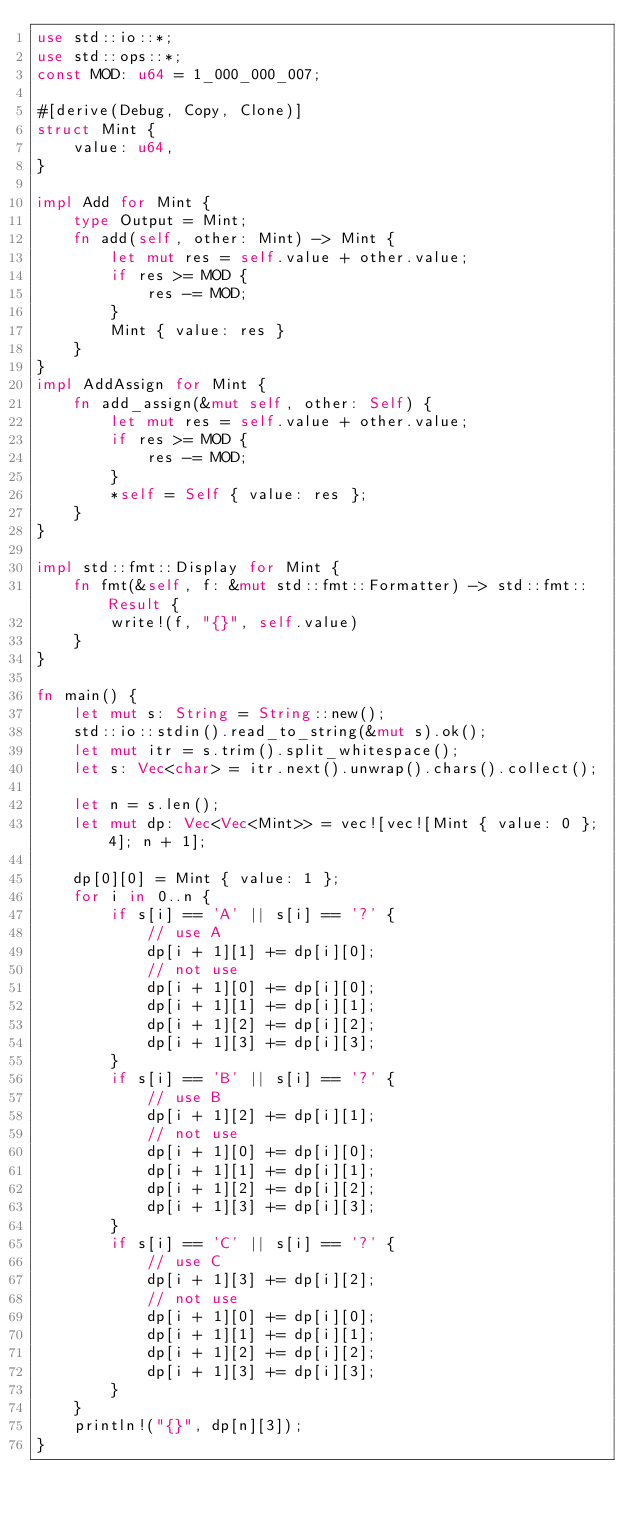Convert code to text. <code><loc_0><loc_0><loc_500><loc_500><_Rust_>use std::io::*;
use std::ops::*;
const MOD: u64 = 1_000_000_007;

#[derive(Debug, Copy, Clone)]
struct Mint {
    value: u64,
}

impl Add for Mint {
    type Output = Mint;
    fn add(self, other: Mint) -> Mint {
        let mut res = self.value + other.value;
        if res >= MOD {
            res -= MOD;
        }
        Mint { value: res }
    }
}
impl AddAssign for Mint {
    fn add_assign(&mut self, other: Self) {
        let mut res = self.value + other.value;
        if res >= MOD {
            res -= MOD;
        }
        *self = Self { value: res };
    }
}

impl std::fmt::Display for Mint {
    fn fmt(&self, f: &mut std::fmt::Formatter) -> std::fmt::Result {
        write!(f, "{}", self.value)
    }
}

fn main() {
    let mut s: String = String::new();
    std::io::stdin().read_to_string(&mut s).ok();
    let mut itr = s.trim().split_whitespace();
    let s: Vec<char> = itr.next().unwrap().chars().collect();

    let n = s.len();
    let mut dp: Vec<Vec<Mint>> = vec![vec![Mint { value: 0 }; 4]; n + 1];

    dp[0][0] = Mint { value: 1 };
    for i in 0..n {
        if s[i] == 'A' || s[i] == '?' {
            // use A
            dp[i + 1][1] += dp[i][0];
            // not use
            dp[i + 1][0] += dp[i][0];
            dp[i + 1][1] += dp[i][1];
            dp[i + 1][2] += dp[i][2];
            dp[i + 1][3] += dp[i][3];
        }
        if s[i] == 'B' || s[i] == '?' {
            // use B
            dp[i + 1][2] += dp[i][1];
            // not use
            dp[i + 1][0] += dp[i][0];
            dp[i + 1][1] += dp[i][1];
            dp[i + 1][2] += dp[i][2];
            dp[i + 1][3] += dp[i][3];
        }
        if s[i] == 'C' || s[i] == '?' {
            // use C
            dp[i + 1][3] += dp[i][2];
            // not use
            dp[i + 1][0] += dp[i][0];
            dp[i + 1][1] += dp[i][1];
            dp[i + 1][2] += dp[i][2];
            dp[i + 1][3] += dp[i][3];
        }
    }
    println!("{}", dp[n][3]);
}
</code> 